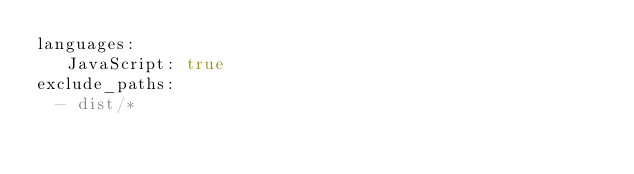<code> <loc_0><loc_0><loc_500><loc_500><_YAML_>languages:
   JavaScript: true
exclude_paths:
  - dist/*
</code> 